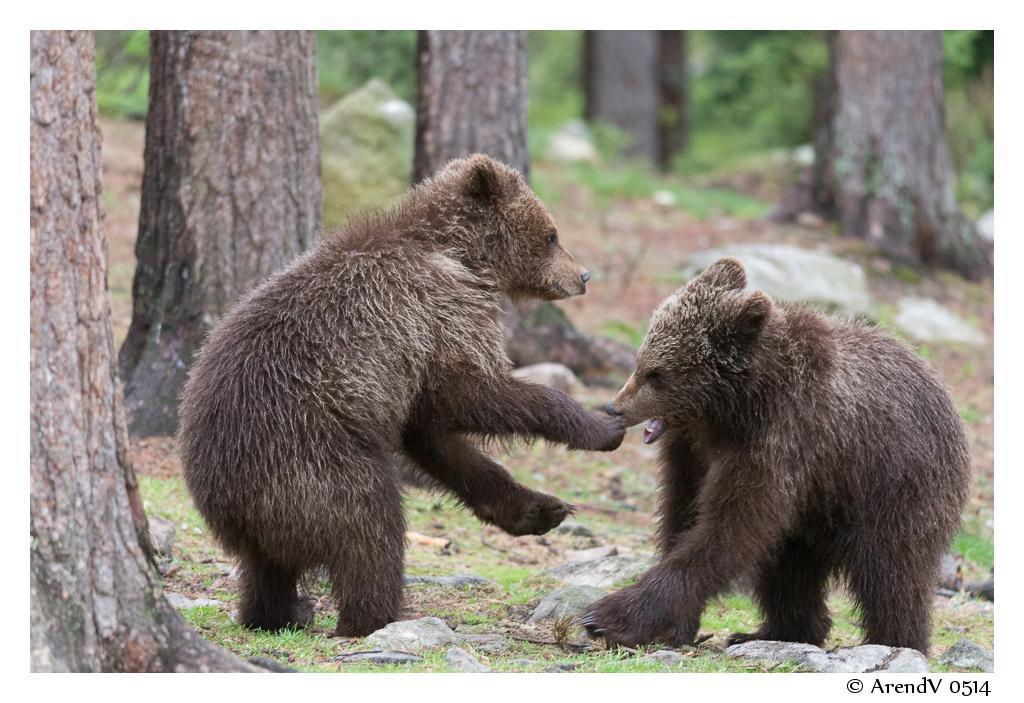Describe this image in one or two sentences. In this image I can see an open grass ground and on it I can see number of stones and two brown colour bears. I can also see number of trees and I can see this image is little bit blurry. On the right side of the image I can see a watermark. 